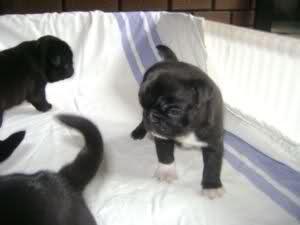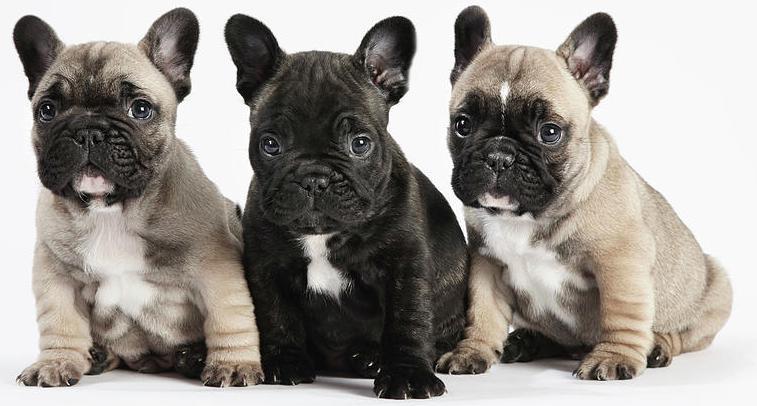The first image is the image on the left, the second image is the image on the right. Examine the images to the left and right. Is the description "Each image contains multiple pugs, and each image includes at least one black pug." accurate? Answer yes or no. Yes. The first image is the image on the left, the second image is the image on the right. Given the left and right images, does the statement "There is exactly one light colored dog with a dark muzzle in each image." hold true? Answer yes or no. No. 